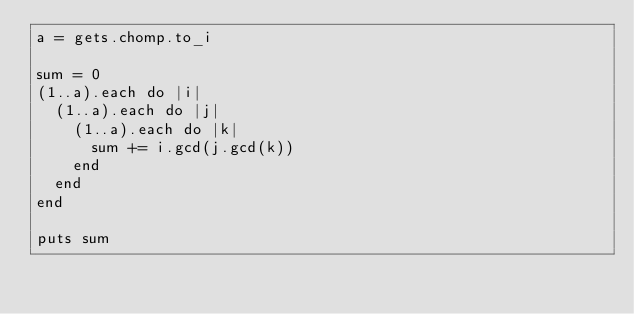Convert code to text. <code><loc_0><loc_0><loc_500><loc_500><_Ruby_>a = gets.chomp.to_i

sum = 0
(1..a).each do |i|
  (1..a).each do |j|
    (1..a).each do |k|
      sum += i.gcd(j.gcd(k))
    end
  end
end

puts sum
</code> 